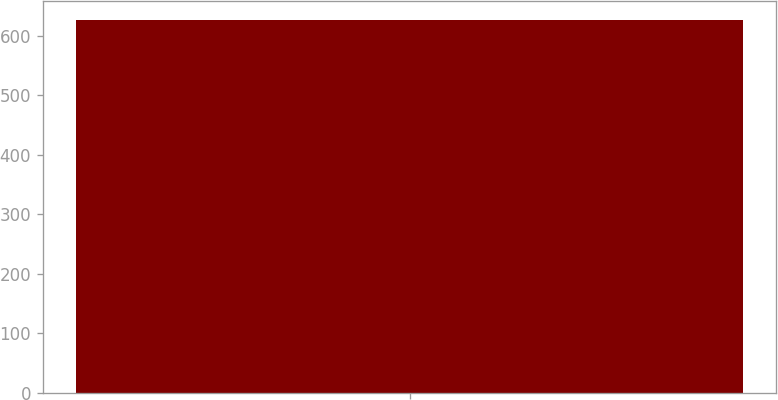<chart> <loc_0><loc_0><loc_500><loc_500><bar_chart><ecel><nl><fcel>627<nl></chart> 